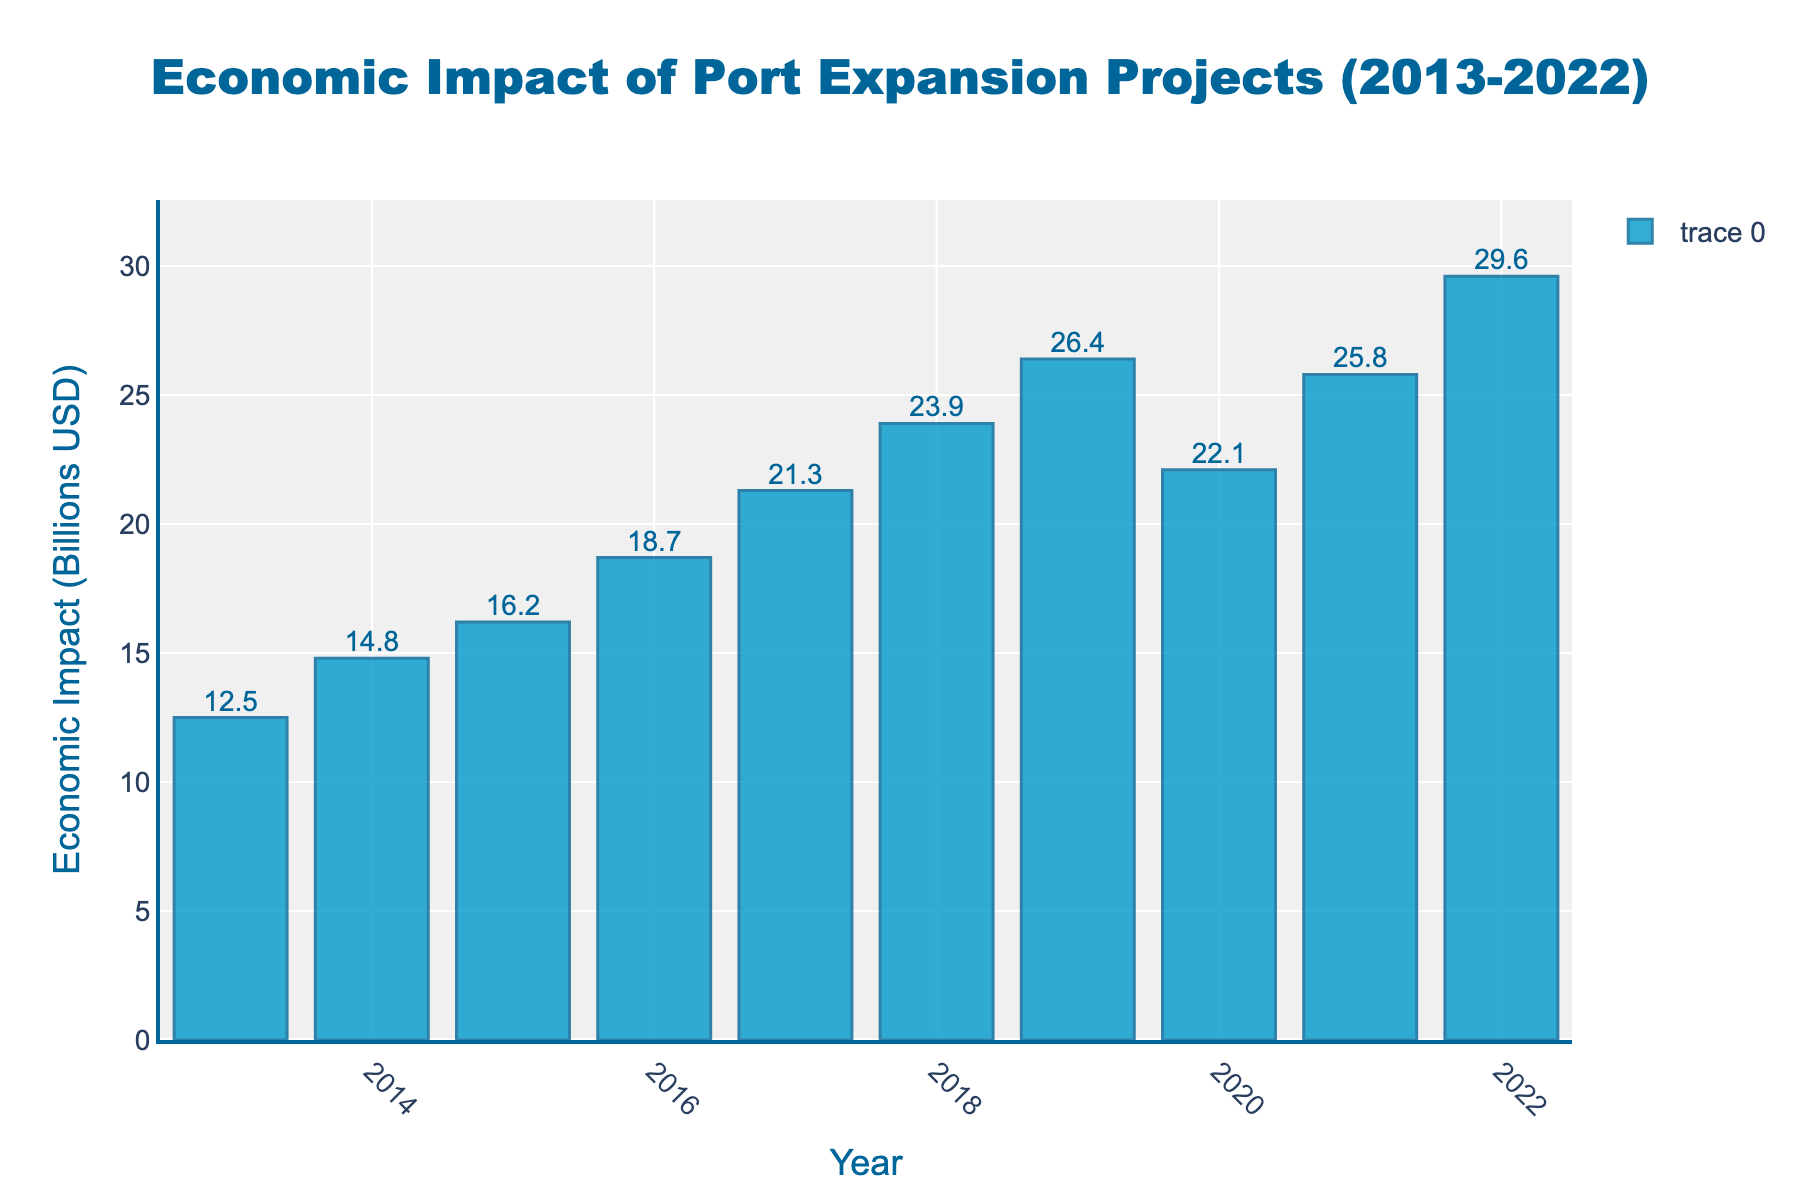What is the economic impact of port expansion projects in 2022? Identify the height of the bar for the year 2022, which represents the economic impact.
Answer: 29.6 billion USD Which year saw the highest economic impact of port expansion projects? Compare the heights of all the bars and find the tallest one, which corresponds to the highest economic impact.
Answer: 2022 How much did the economic impact increase from 2013 to 2022? Subtract the economic impact in 2013 from the economic impact in 2022: 29.6 billion USD - 12.5 billion USD.
Answer: 17.1 billion USD What was the average economic impact of the port expansion projects over the decade? Sum all the economic impacts from 2013 to 2022 and divide by the number of years (10): (12.5 + 14.8 + 16.2 + 18.7 + 21.3 + 23.9 + 26.4 + 22.1 + 25.8 + 29.6) / 10.
Answer: 21.13 billion USD Which year experienced a decrease in the economic impact compared to the previous year? Compare each year's economic impact to the previous year's and identify the year where there is a decrease. 2020's economic impact was 22.1 billion USD while 2019’s was 26.4 billion USD.
Answer: 2020 What was the cumulative economic impact of the port expansion projects from 2013 to 2016? Sum the economic impacts from 2013 to 2016: 12.5 billion USD + 14.8 billion USD + 16.2 billion USD + 18.7 billion USD.
Answer: 62.2 billion USD By how much did the economic impact change from 2019 to 2020? Subtract the economic impact in 2020 from the economic impact in 2019: 26.4 billion USD - 22.1 billion USD.
Answer: 4.3 billion USD What is the median economic impact over the decade? Arrange the economic impacts in ascending order and find the middle value, or the average of the two middle values if there is an even number of data points. For 10 values, median is the average of the 5th (21.3 billion USD) and 6th (23.9 billion USD) values.
Answer: 22.6 billion USD How much higher was the economic impact in 2017 compared to 2016? Subtract the economic impact in 2016 from the economic impact in 2017: 21.3 billion USD - 18.7 billion USD.
Answer: 2.6 billion USD What is the color of the bars in the chart? Observe the color of the bars representing the economic impact in the figure.
Answer: Blue 